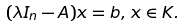<formula> <loc_0><loc_0><loc_500><loc_500>( \lambda I _ { n } - A ) x = b , \, x \in K .</formula> 